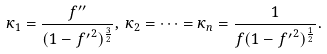<formula> <loc_0><loc_0><loc_500><loc_500>\kappa _ { 1 } = \frac { f ^ { \prime \prime } } { ( 1 - { f ^ { \prime } } ^ { 2 } ) ^ { \frac { 3 } { 2 } } } , \, \kappa _ { 2 } = \dots = \kappa _ { n } = \frac { 1 } { f ( 1 - { f ^ { \prime } } ^ { 2 } ) ^ { \frac { 1 } { 2 } } } .</formula> 